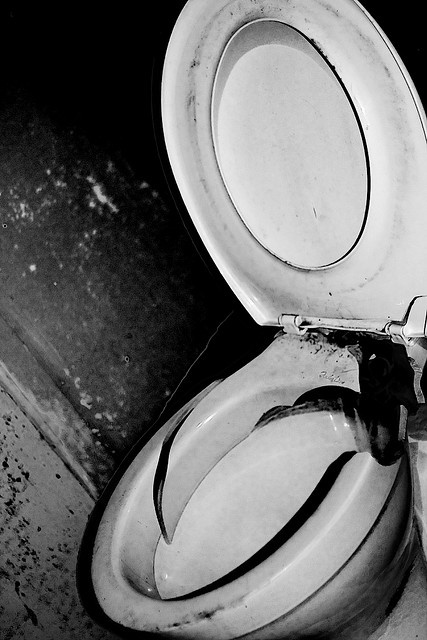Describe the objects in this image and their specific colors. I can see a toilet in black, lightgray, darkgray, and gray tones in this image. 